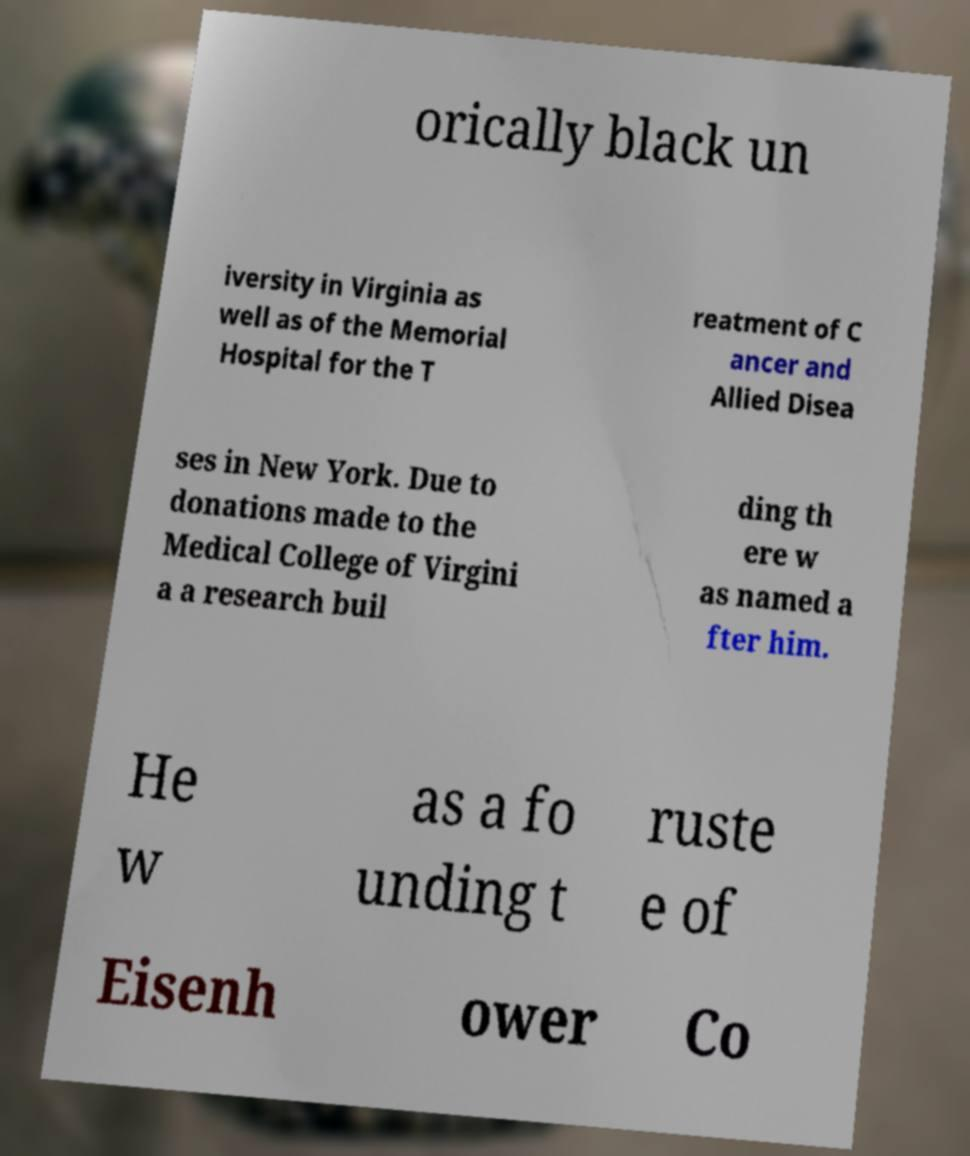Can you accurately transcribe the text from the provided image for me? orically black un iversity in Virginia as well as of the Memorial Hospital for the T reatment of C ancer and Allied Disea ses in New York. Due to donations made to the Medical College of Virgini a a research buil ding th ere w as named a fter him. He w as a fo unding t ruste e of Eisenh ower Co 